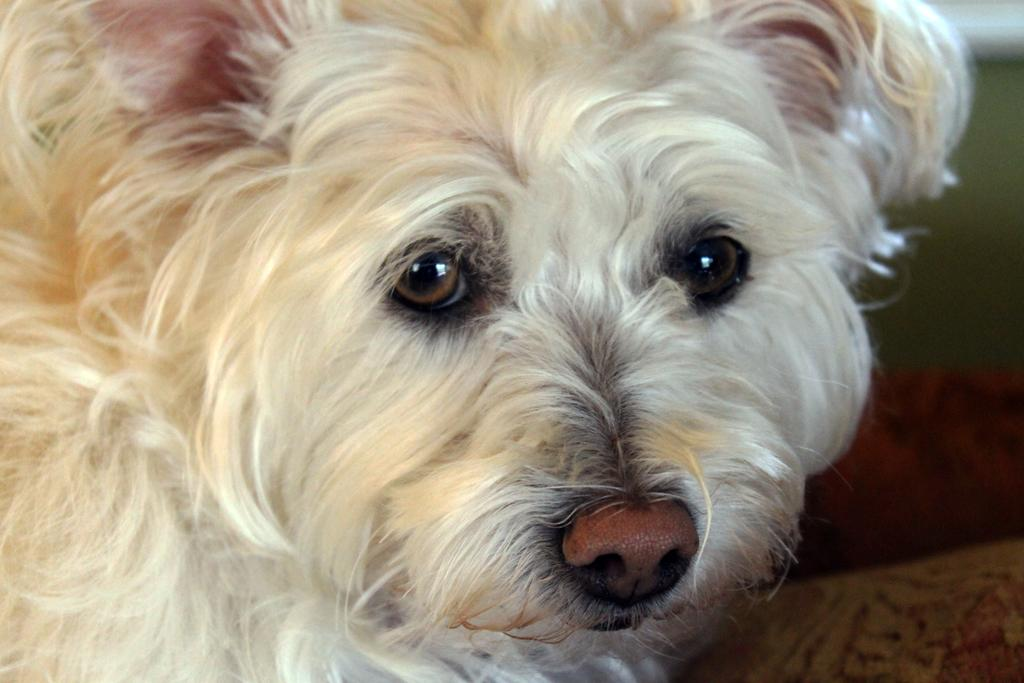What type of animal is present in the image? There is a dog in the image. What type of fruit is the dog holding in its hands in the image? There is no fruit or hands present in the image, and the dog is not holding anything. 